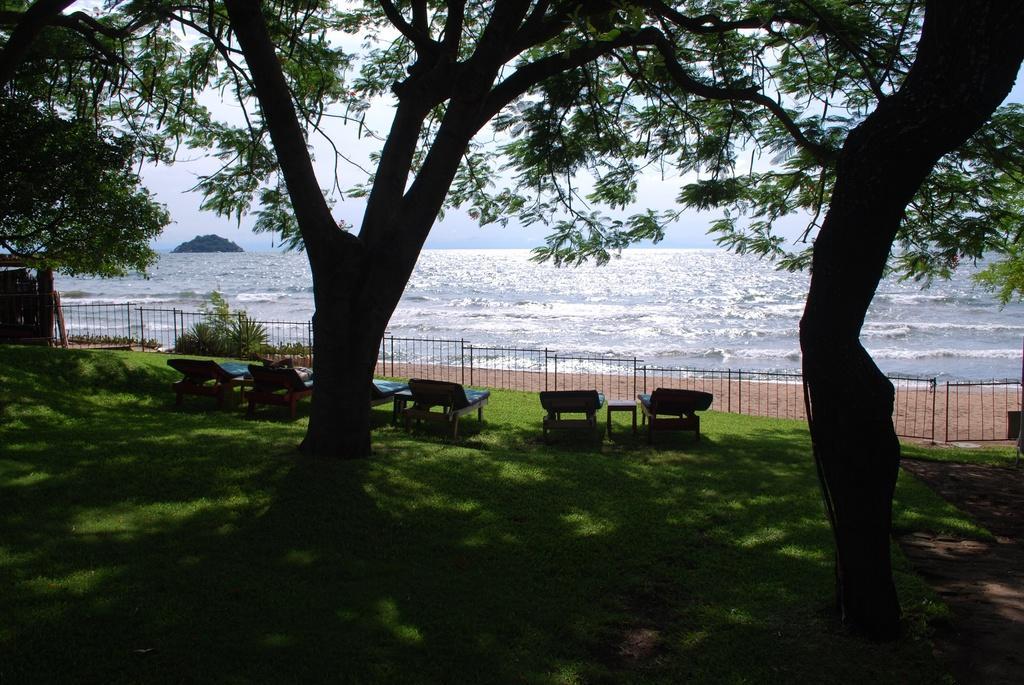In one or two sentences, can you explain what this image depicts? In this image I can see trees. There are chairs, tables, iron grilles or barriers and there is grass. Also there is water, a hill and in the background there is sky. 